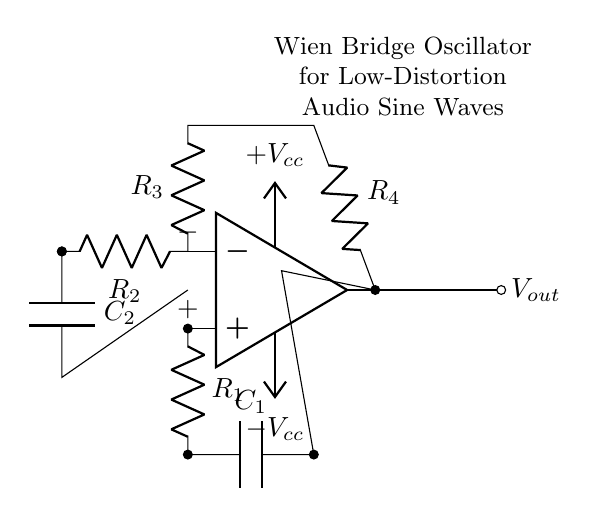What is the component connected to the non-inverting input of the op-amp? The component connected to the non-inverting input is a resistor labeled R1 connected to a capacitor C1 in a feedback network.
Answer: R1 What is the value of Vout? Vout is the output voltage of the oscillator circuit generated at the output of the op-amp.
Answer: Vout What is the role of R2 in the circuit? R2, along with the capacitor C2, is part of the Wien bridge network that helps set the frequency of oscillation in the circuit.
Answer: Frequency setting component What happens if the values of R3 and R4 are equal? If R3 and R4 are equal, the circuit may fail to balance correctly, possibly affecting the stability and amplitude of oscillations.
Answer: Affects stability How does the power supply influence the operation of the Wien bridge oscillator? The power supply provides the necessary voltage levels to the op-amp, allowing it to perform amplification and oscillation. Without it, the oscillator wouldn't function.
Answer: Provides necessary voltage What is the purpose of C1 in the feedback network? C1 is used for phase shift purposes, helping to achieve the necessary 180-degree phase shift for the oscillator to function correctly.
Answer: Phase shift What type of output waveform is produced by this circuit? The output waveform produced by this circuit is a low-distortion sine wave, suitable for audio applications due to the configuration of the Wien bridge oscillator.
Answer: Sine wave 